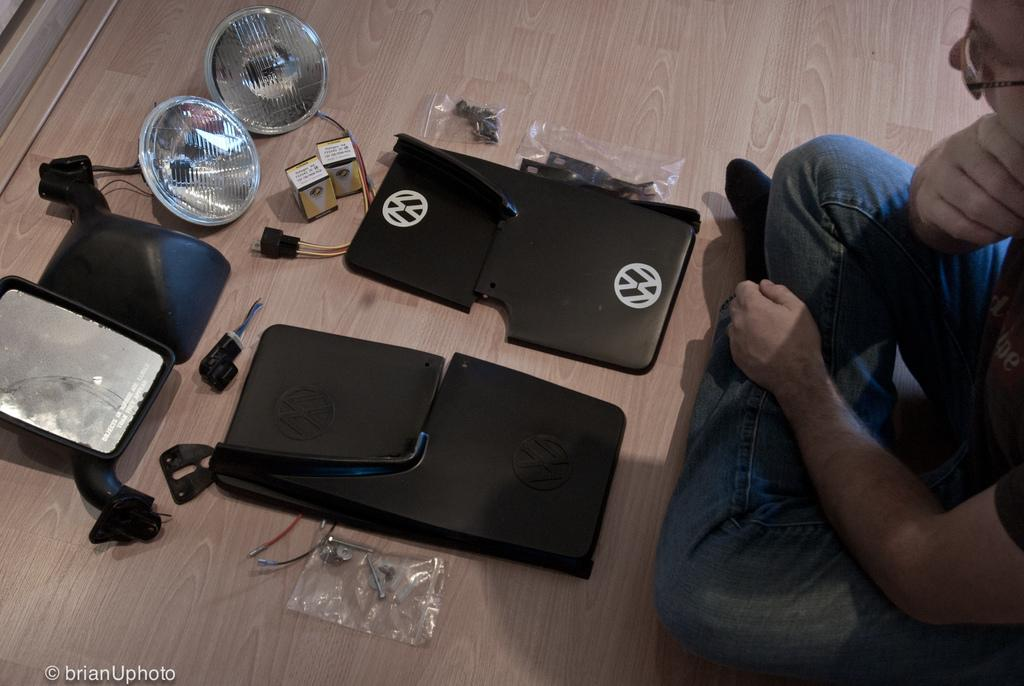What is the person in the image doing? The person is sitting on the floor in the image. What can be seen in the background or surroundings of the person? There are lights visible in the image. Can you describe any other objects present in the image? There are other objects present in the image, but their specific details are not mentioned in the provided facts. What type of plant is the carpenter using to listen to the person's ear in the image? There is no plant, carpenter, or ear present in the image. 